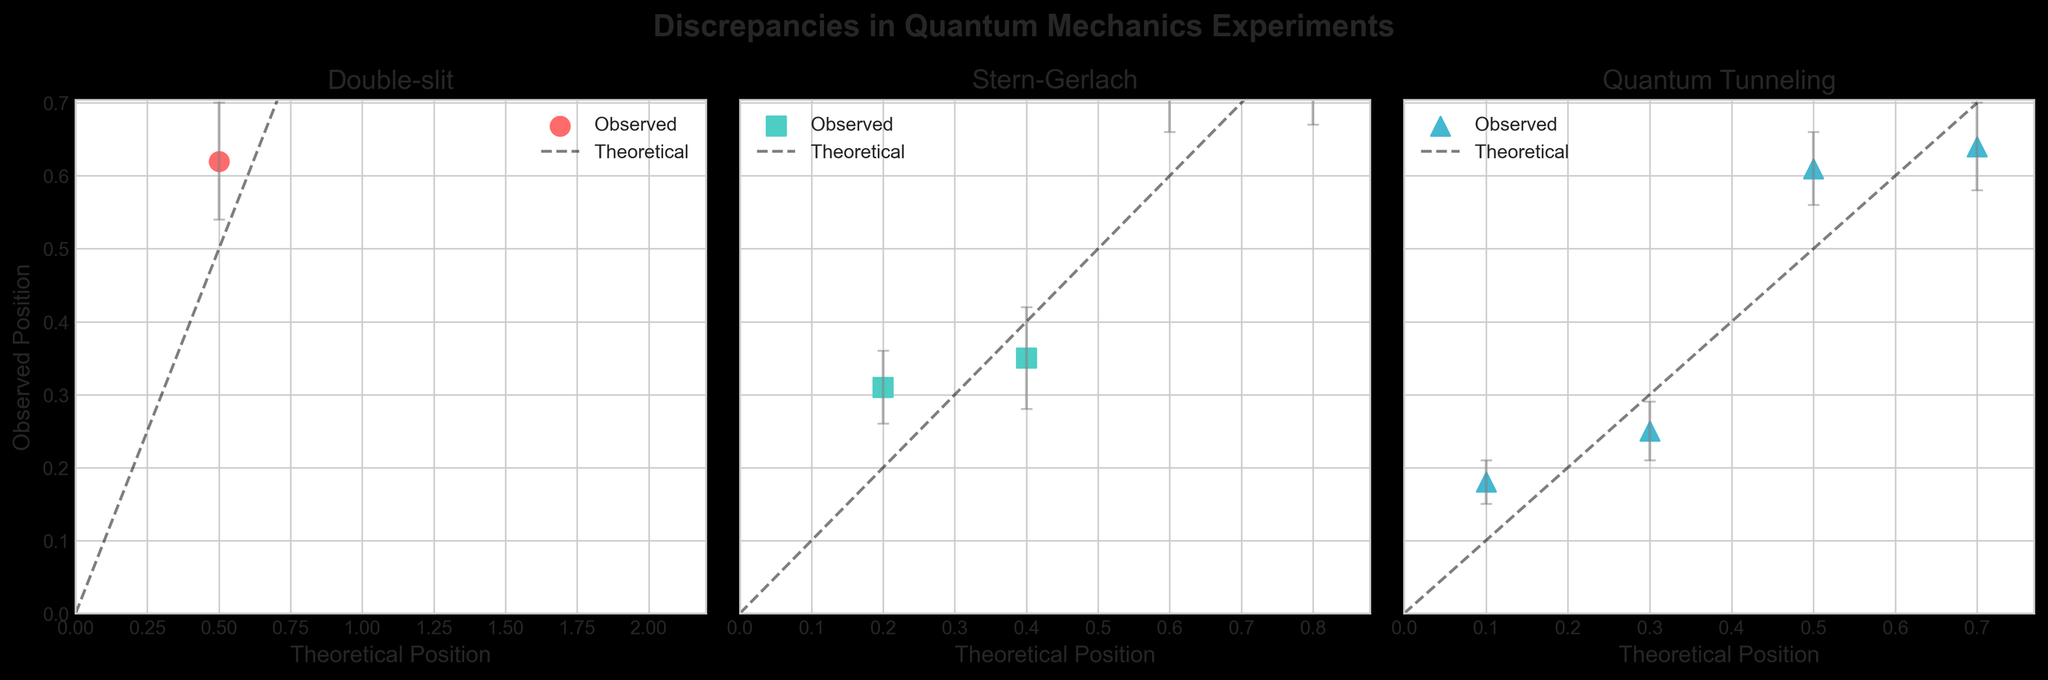What is the title of the plot? The title is centered at the top of the plot. It states "Discrepancies in Quantum Mechanics Experiments".
Answer: Discrepancies in Quantum Mechanics Experiments What are the names of the three experiments shown in the subplot? The subplot contains the titles of the individual scatter plots that read from left to right as "Double slit", "Stern Gerlach", and "Quantum Tunneling".
Answer: Double slit, Stern Gerlach, Quantum Tunneling In the Double slit subplot, how many data points are there? By counting the scatter points in the Double slit subplot, we see there are four data points.
Answer: 4 What are the axes labeled in the Stern Gerlach subplot? The x-axis is labeled "Theoretical Position", and the y-axis is labeled "Observed Position" like in the other subplots.
Answer: Theoretical Position, Observed Position Which subplot shows the largest observed discrepancy between theoretical and observed positions? By visually comparing the distances between data points and the theoretical diagonal line in all three subplots, the Double slit plot shows the largest discrepancy.
Answer: Double slit What color markers are used for each experiment? The markers in the Double slit subplot are red, those in the Stern Gerlach subplot are turquoise, and those in the Quantum Tunneling subplot are light blue.
Answer: Red for Double slit, Turquoise for Stern Gerlach, Light blue for Quantum Tunneling What is the maximum observed position in the Quantum Tunneling subplot? The highest scatter point on the y-axis of the Quantum Tunneling subplot is slightly above 0.6.
Answer: 0.64 Which experiment has the smallest uncertainty? By observing the error bars in each subplot, the Quantum Tunneling experiment shows the smallest uncertainty with the lower magnitude of error bars compared to the others.
Answer: Quantum Tunneling Compare the theoretical and observed positions at the 0.6 theoretical position in the Stern Gerlach subplot. Is the observed position higher or lower than the theoretical position? The observed position at the 0.6 theoretical position is significantly higher, around 0.72, on the y-axis.
Answer: Higher What is the range of the theoretical positions covered in the Double slit subplot? The theoretical positions in the Double slit subplot range from 0.5 to 2.0, as seen from the x-axis ticks.
Answer: 0.5 to 2.0 